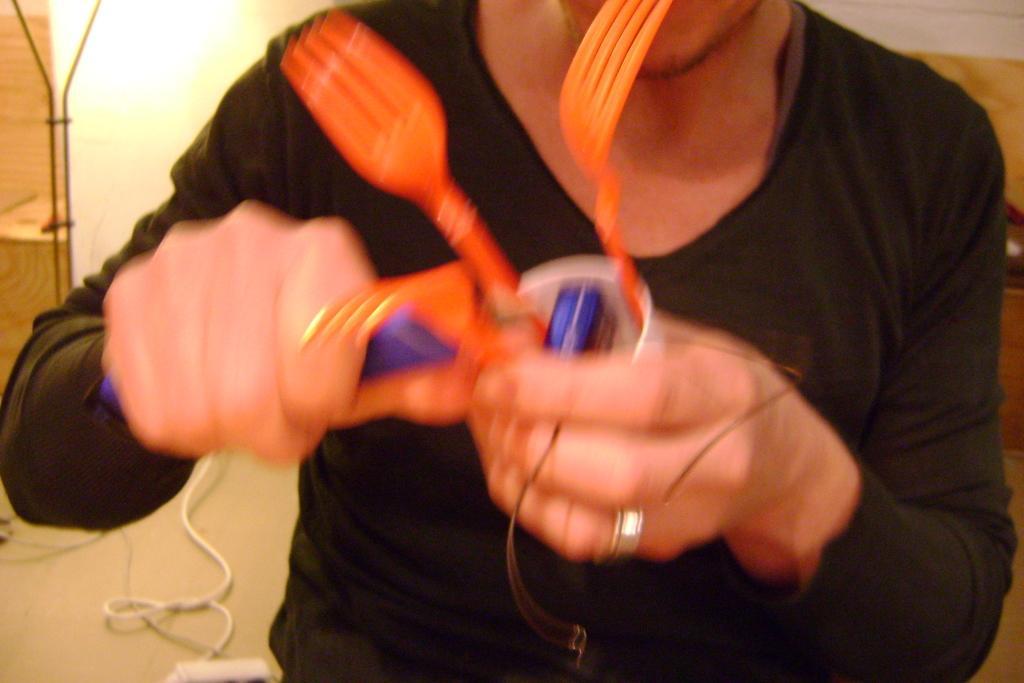How would you summarize this image in a sentence or two? In the middle of this image, there is a person in a black color t-shirt, holding a cup, in which there are two yellow color forks with a hand, and holding an orange color object with other hand. In the background, there is light, a wall and other objects. 